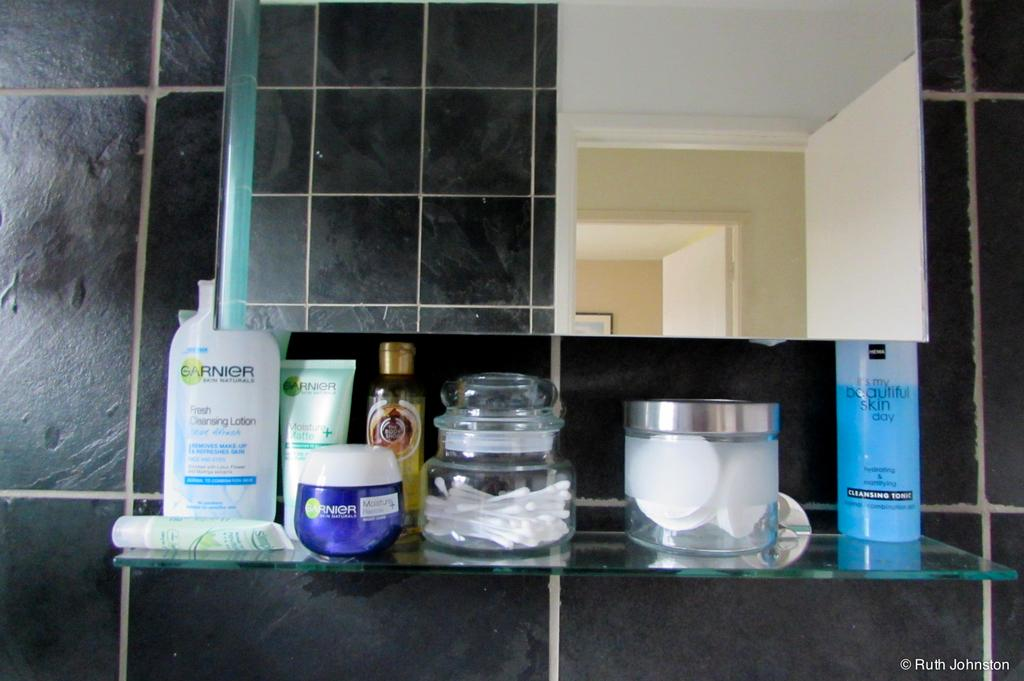What personal care products are visible in the image? There is a shampoo and a face wash in the image. What type of container is present in the image? There is a glass jar in the image. What can be used for cleaning or wiping in the image? Tissues are present in the image. Where is the jar located in the image? There is a jar in the rack in the image. What can be seen in the background of the image? There is a mirror and a wall in the background of the image. What type of sticks are used to apply the shampoo in the image? There are no sticks present in the image, and the shampoo is not being applied in the image. How does the face wash rub against the skin in the image? The face wash is not being applied or rubbed against the skin in the image. 